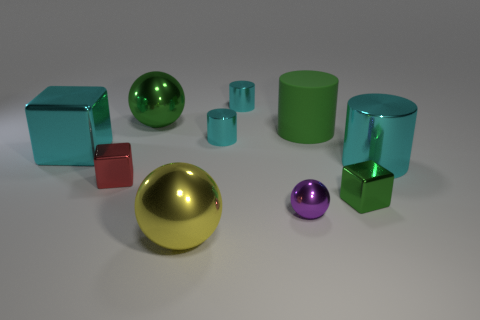Subtract all cyan spheres. How many cyan cylinders are left? 3 Subtract all blocks. How many objects are left? 7 Subtract all gray rubber objects. Subtract all cyan metallic things. How many objects are left? 6 Add 6 cylinders. How many cylinders are left? 10 Add 3 blue metal cylinders. How many blue metal cylinders exist? 3 Subtract 0 brown cylinders. How many objects are left? 10 